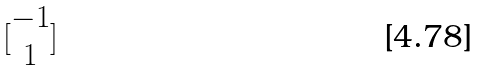Convert formula to latex. <formula><loc_0><loc_0><loc_500><loc_500>[ \begin{matrix} - 1 \\ 1 \end{matrix} ]</formula> 